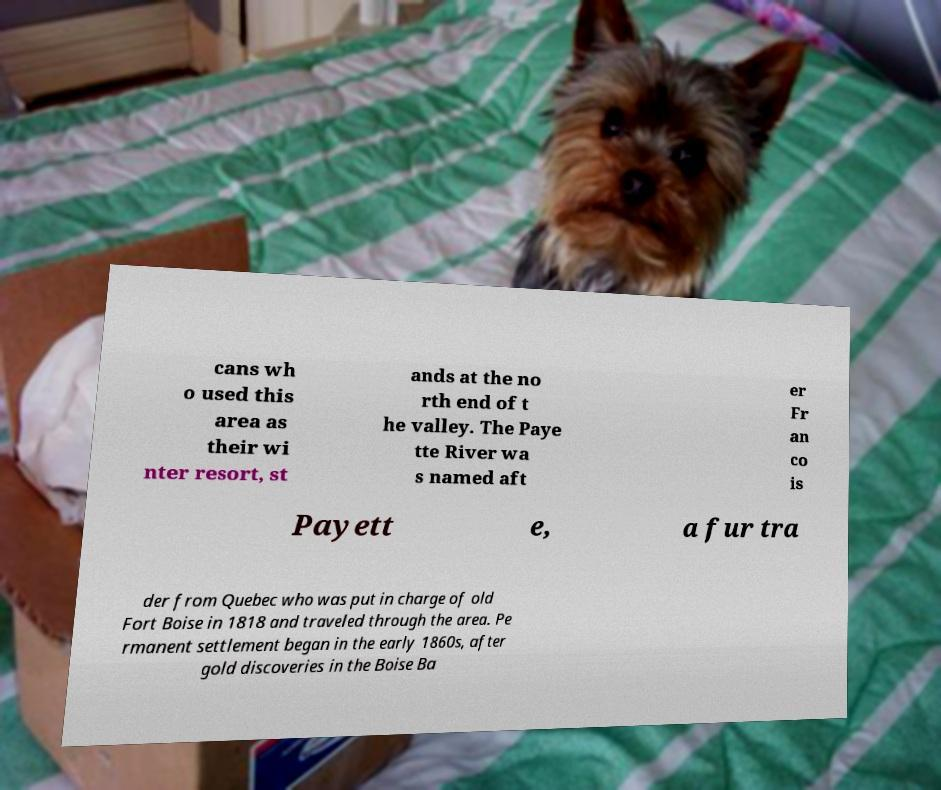I need the written content from this picture converted into text. Can you do that? cans wh o used this area as their wi nter resort, st ands at the no rth end of t he valley. The Paye tte River wa s named aft er Fr an co is Payett e, a fur tra der from Quebec who was put in charge of old Fort Boise in 1818 and traveled through the area. Pe rmanent settlement began in the early 1860s, after gold discoveries in the Boise Ba 